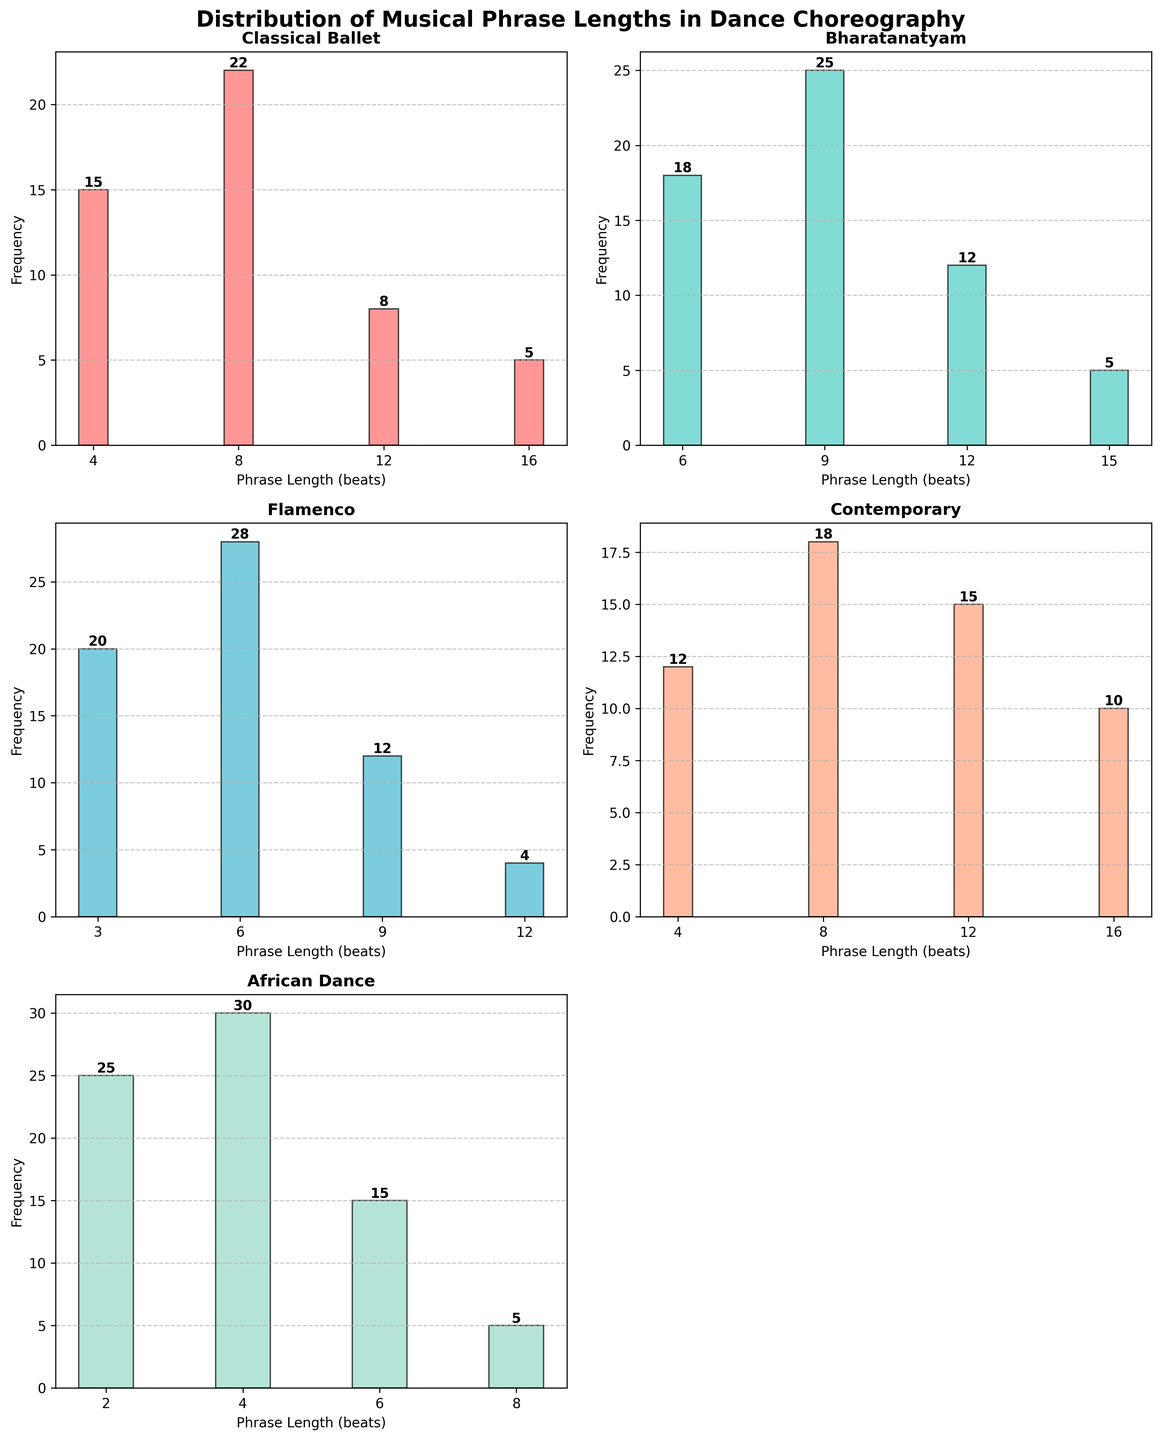What's the title of the figure? The title of the figure is displayed at the top and reads 'Distribution of Musical Phrase Lengths in Dance Choreography'.
Answer: Distribution of Musical Phrase Lengths in Dance Choreography How many subplots are there in total? There are six subplot spaces, but one is intentionally left empty, making it visually five populated subplots.
Answer: Six Which culture has the most frequent phrase at length 6 beats? By looking at the heights of the bars for length 6 phrases, we see that Bharatanatyam, Flamenco, and African Dance have significant frequencies. The highest bar is for Flamenco at 28 beats.
Answer: Flamenco What is the frequency of 4-beat phrases in Classical Ballet? Locate the bar corresponding to 4-beat phrases in the 'Classical Ballet' subplot. The height of the bar is labeled 15.
Answer: 15 Which culture has the visual highest frequency across all phrase lengths and what is the frequency value? By examining the histograms, the tallest bar across all subplots belongs to the 'African Dance' subplot with a frequency of 30 at 4-beats.
Answer: African Dance, 30 How many phrases are there of length 12 beats in the Contemporary subplot, and how does it compare to the number of 12-beat phrases in Bharatanatyam? For Contemporary, the frequency of 12-beat phrases is 15. For Bharatanatyam, it is 12. Hence, Contemporary has three more 12-beat phrases than Bharatanatyam.
Answer: Contemporary has 15; it is 3 more than Bharatanatyam Which subplot contains the smallest number of different phrase lengths and what is that number? By counting the bars in each subplot, Classical Ballet has 4 different phrase lengths, which is the smallest number compared to other subplots.
Answer: Classical Ballet, 4 If you were to sum the frequencies of the 8-beat phrases in all cultures, what would be the total sum? The 8-beat frequencies are as follows: Classical Ballet (22), Bharatanatyam (0), Flamenco (0), Contemporary (18), African Dance (5). Summing these gives 22 + 0 + 0 + 18 + 5 = 45.
Answer: 45 Which culture has the phrase length spectrum closest to an arithmetically increasing sequence of 3, and what sequence is it? Flamenco's phrase lengths are 3, 6, 9, and 12, which is an arithmetic sequence increasing by 3.
Answer: Flamenco, 3, 6, 9, 12 